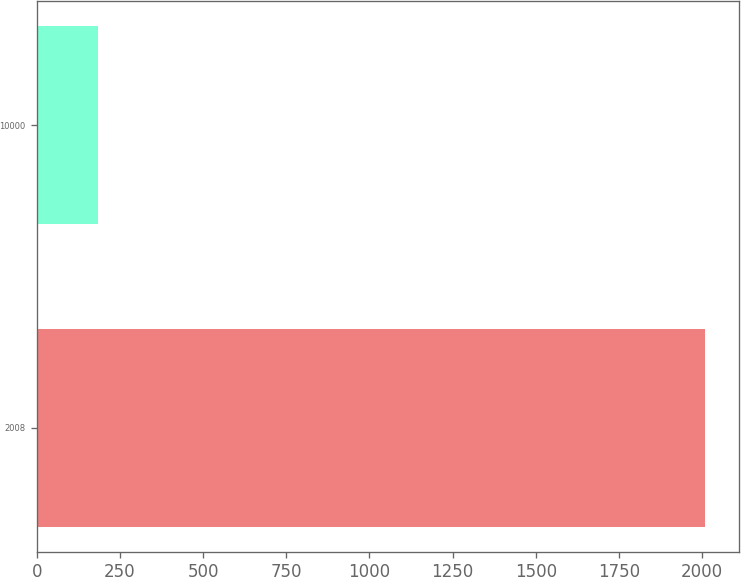Convert chart. <chart><loc_0><loc_0><loc_500><loc_500><bar_chart><fcel>2008<fcel>10000<nl><fcel>2010<fcel>183.5<nl></chart> 